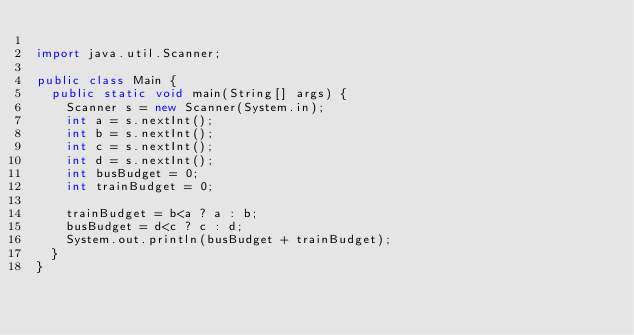<code> <loc_0><loc_0><loc_500><loc_500><_Java_>
import java.util.Scanner;

public class Main {
	public static void main(String[] args) {
		Scanner s = new Scanner(System.in);
		int a = s.nextInt();
		int b = s.nextInt();
		int c = s.nextInt();
		int d = s.nextInt();
		int busBudget = 0;
		int trainBudget = 0;

		trainBudget = b<a ? a : b;
		busBudget = d<c ? c : d;
		System.out.println(busBudget + trainBudget);
	}
}</code> 